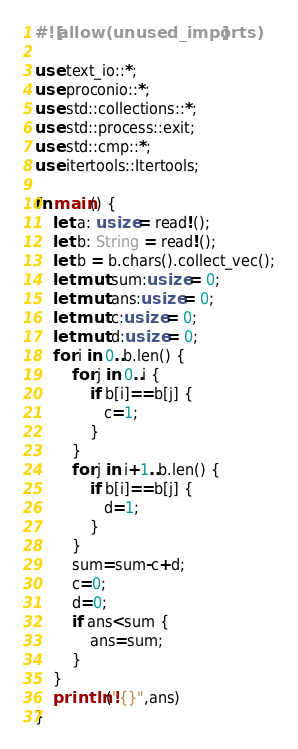Convert code to text. <code><loc_0><loc_0><loc_500><loc_500><_Rust_>#![allow(unused_imports)]

use text_io::*;
use proconio::*;
use std::collections::*;
use std::process::exit;
use std::cmp::*;
use itertools::Itertools;

fn main() {
    let a: usize = read!();
    let b: String = read!();
    let b = b.chars().collect_vec();
    let mut sum:usize = 0;
    let mut ans:usize = 0;
    let mut c:usize = 0;
    let mut d:usize = 0;
    for i in 0..b.len() {
        for j in 0..i {
            if b[i]==b[j] {
               c=1;
            }
        }
        for j in i+1..b.len() {
            if b[i]==b[j] {
               d=1;
            }
        }
        sum=sum-c+d;
        c=0;
        d=0;
        if ans<sum {
            ans=sum;
        }
    }
    println!("{}",ans)
}</code> 